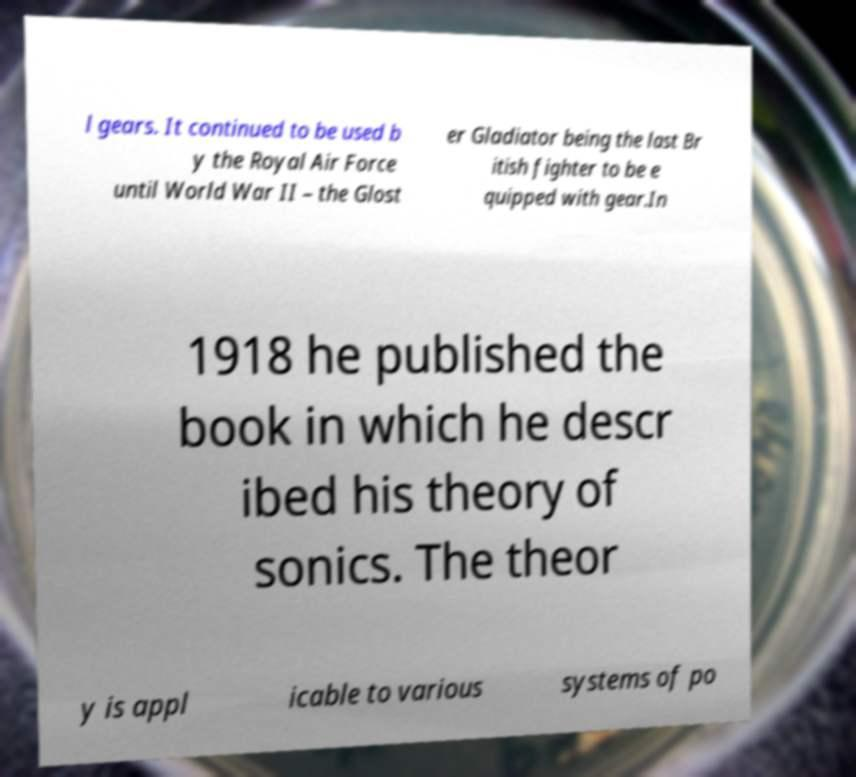What messages or text are displayed in this image? I need them in a readable, typed format. l gears. It continued to be used b y the Royal Air Force until World War II – the Glost er Gladiator being the last Br itish fighter to be e quipped with gear.In 1918 he published the book in which he descr ibed his theory of sonics. The theor y is appl icable to various systems of po 